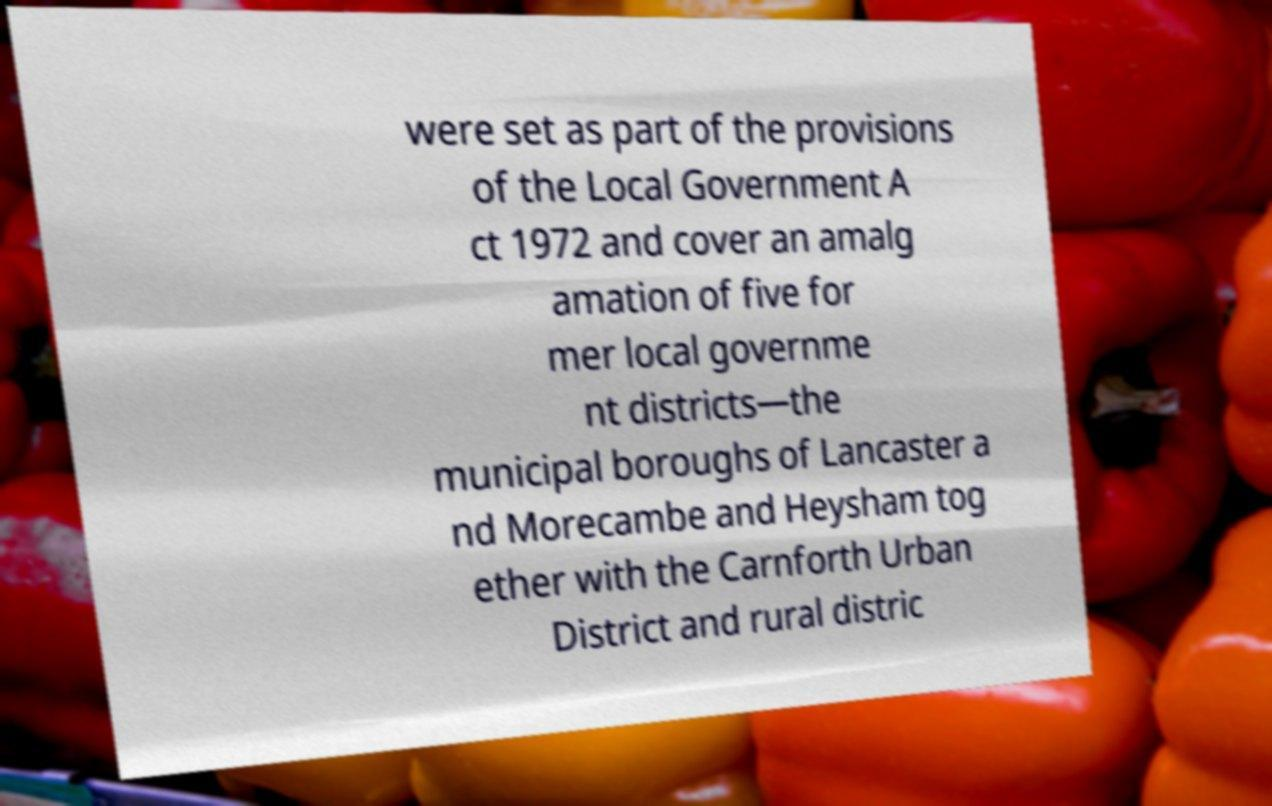Can you accurately transcribe the text from the provided image for me? were set as part of the provisions of the Local Government A ct 1972 and cover an amalg amation of five for mer local governme nt districts—the municipal boroughs of Lancaster a nd Morecambe and Heysham tog ether with the Carnforth Urban District and rural distric 